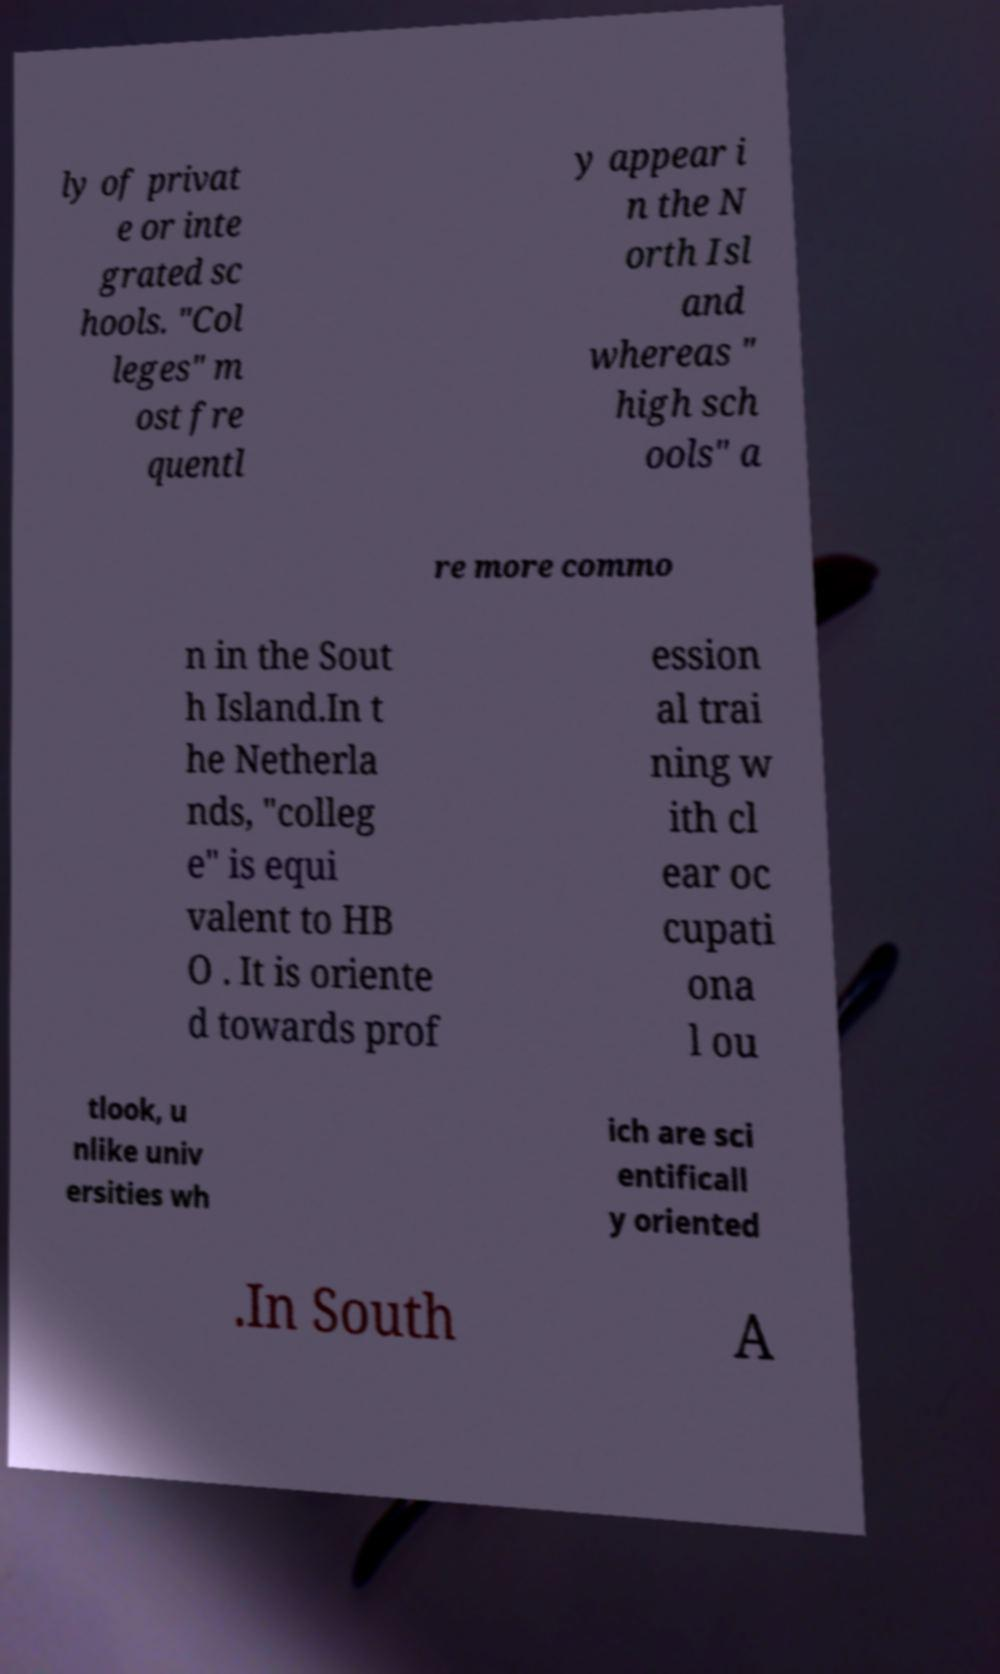Can you read and provide the text displayed in the image?This photo seems to have some interesting text. Can you extract and type it out for me? ly of privat e or inte grated sc hools. "Col leges" m ost fre quentl y appear i n the N orth Isl and whereas " high sch ools" a re more commo n in the Sout h Island.In t he Netherla nds, "colleg e" is equi valent to HB O . It is oriente d towards prof ession al trai ning w ith cl ear oc cupati ona l ou tlook, u nlike univ ersities wh ich are sci entificall y oriented .In South A 